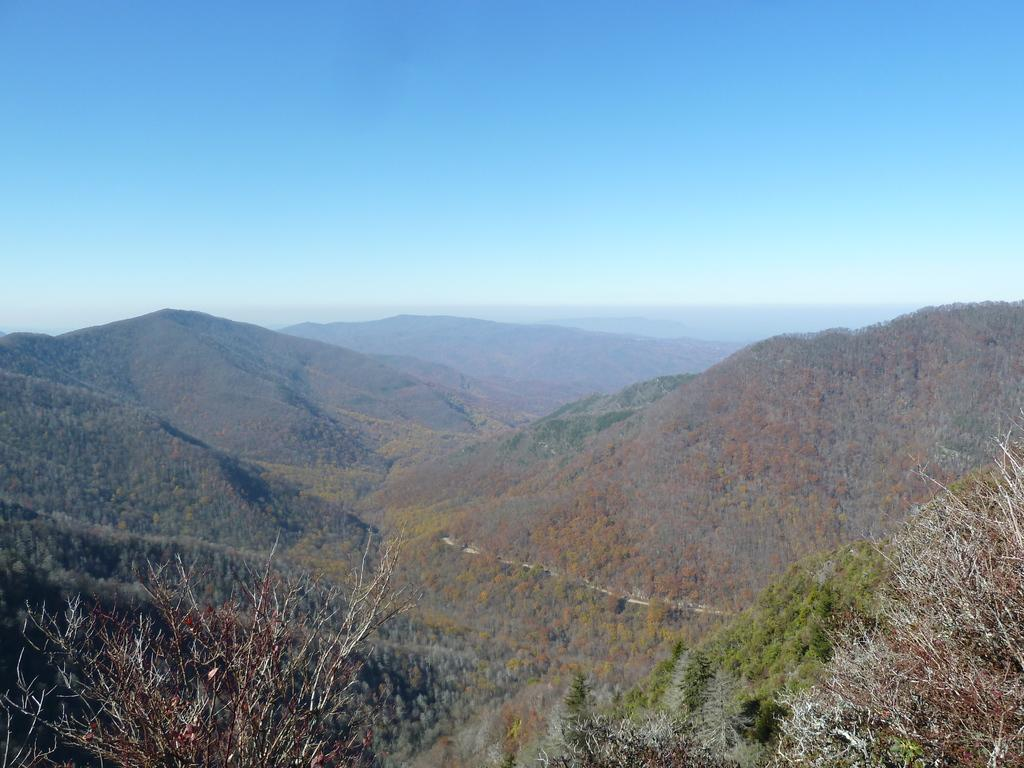What type of natural elements can be seen in the image? There are trees and mountains in the image. What is visible in the background of the image? The sky is visible in the background of the image. What type of shoe can be seen hanging from the tree in the image? There is no shoe present in the image; it only features trees, mountains, and the sky. 